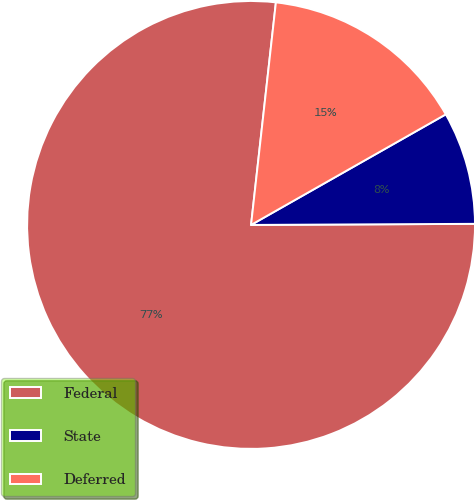Convert chart. <chart><loc_0><loc_0><loc_500><loc_500><pie_chart><fcel>Federal<fcel>State<fcel>Deferred<nl><fcel>76.84%<fcel>8.14%<fcel>15.01%<nl></chart> 